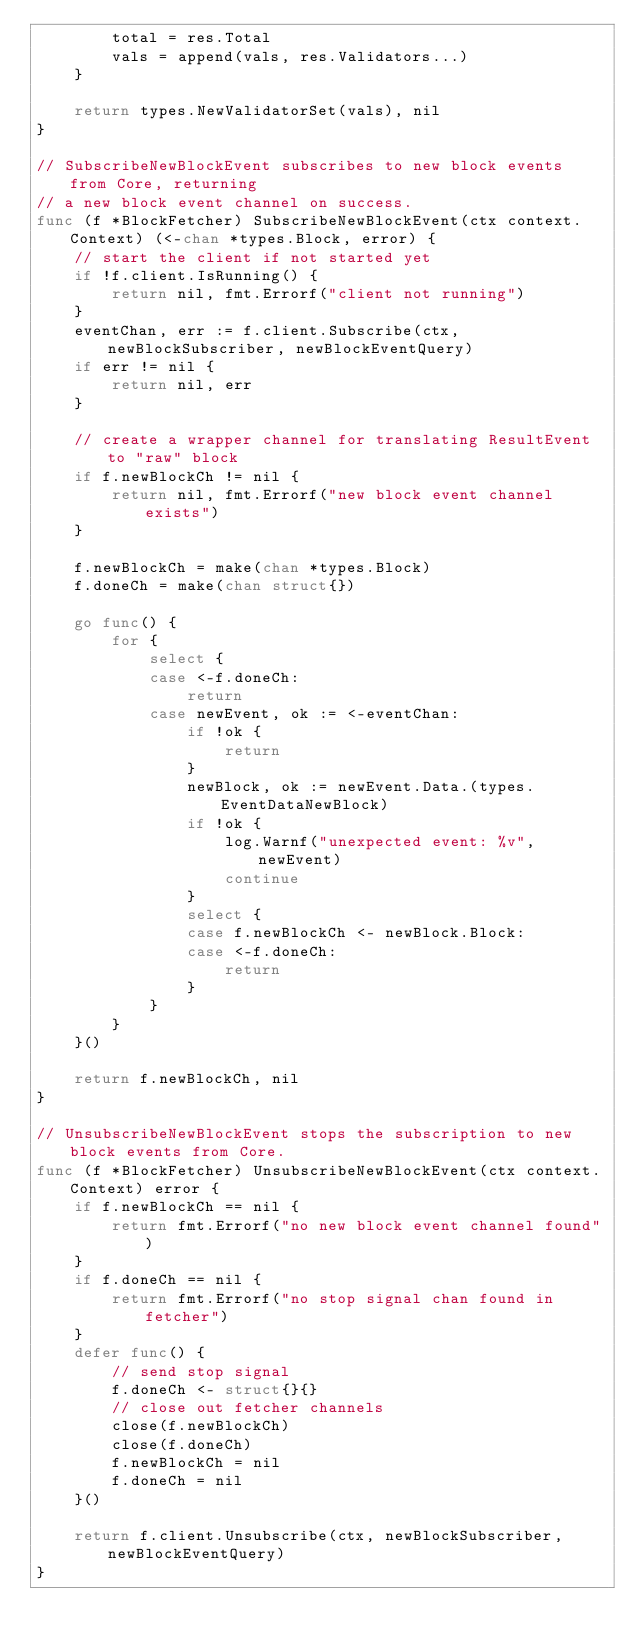Convert code to text. <code><loc_0><loc_0><loc_500><loc_500><_Go_>		total = res.Total
		vals = append(vals, res.Validators...)
	}

	return types.NewValidatorSet(vals), nil
}

// SubscribeNewBlockEvent subscribes to new block events from Core, returning
// a new block event channel on success.
func (f *BlockFetcher) SubscribeNewBlockEvent(ctx context.Context) (<-chan *types.Block, error) {
	// start the client if not started yet
	if !f.client.IsRunning() {
		return nil, fmt.Errorf("client not running")
	}
	eventChan, err := f.client.Subscribe(ctx, newBlockSubscriber, newBlockEventQuery)
	if err != nil {
		return nil, err
	}

	// create a wrapper channel for translating ResultEvent to "raw" block
	if f.newBlockCh != nil {
		return nil, fmt.Errorf("new block event channel exists")
	}

	f.newBlockCh = make(chan *types.Block)
	f.doneCh = make(chan struct{})

	go func() {
		for {
			select {
			case <-f.doneCh:
				return
			case newEvent, ok := <-eventChan:
				if !ok {
					return
				}
				newBlock, ok := newEvent.Data.(types.EventDataNewBlock)
				if !ok {
					log.Warnf("unexpected event: %v", newEvent)
					continue
				}
				select {
				case f.newBlockCh <- newBlock.Block:
				case <-f.doneCh:
					return
				}
			}
		}
	}()

	return f.newBlockCh, nil
}

// UnsubscribeNewBlockEvent stops the subscription to new block events from Core.
func (f *BlockFetcher) UnsubscribeNewBlockEvent(ctx context.Context) error {
	if f.newBlockCh == nil {
		return fmt.Errorf("no new block event channel found")
	}
	if f.doneCh == nil {
		return fmt.Errorf("no stop signal chan found in fetcher")
	}
	defer func() {
		// send stop signal
		f.doneCh <- struct{}{}
		// close out fetcher channels
		close(f.newBlockCh)
		close(f.doneCh)
		f.newBlockCh = nil
		f.doneCh = nil
	}()

	return f.client.Unsubscribe(ctx, newBlockSubscriber, newBlockEventQuery)
}
</code> 